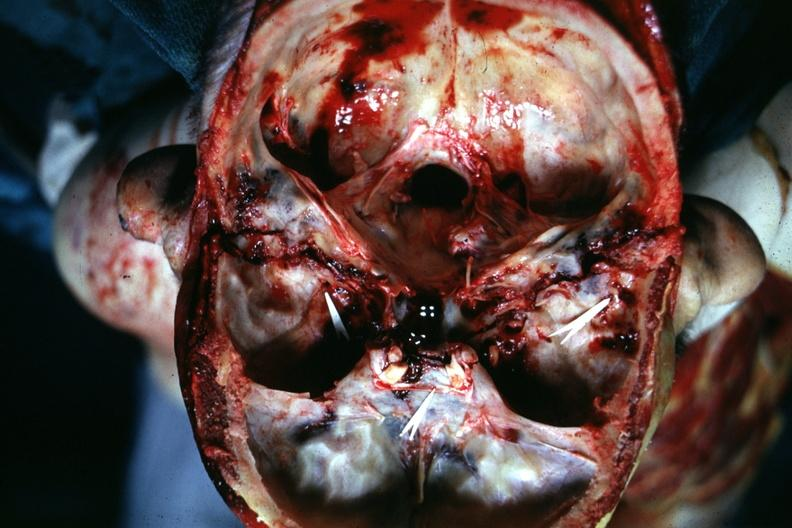what is present?
Answer the question using a single word or phrase. Basilar skull fracture 